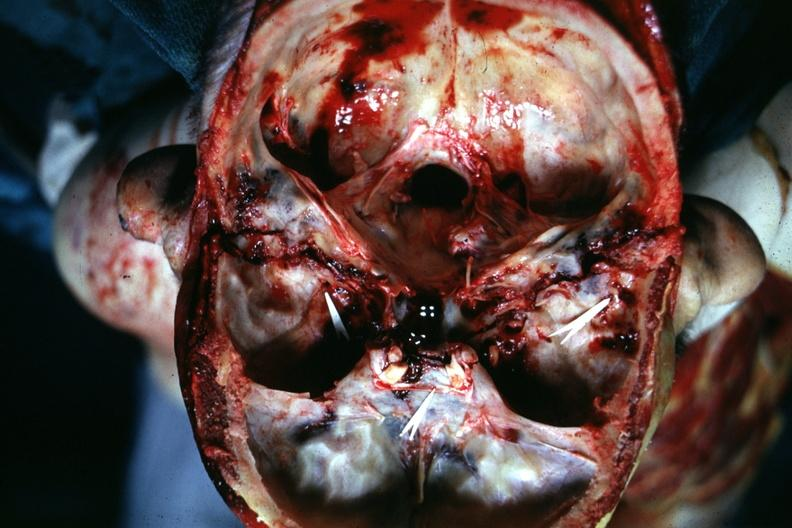what is present?
Answer the question using a single word or phrase. Basilar skull fracture 